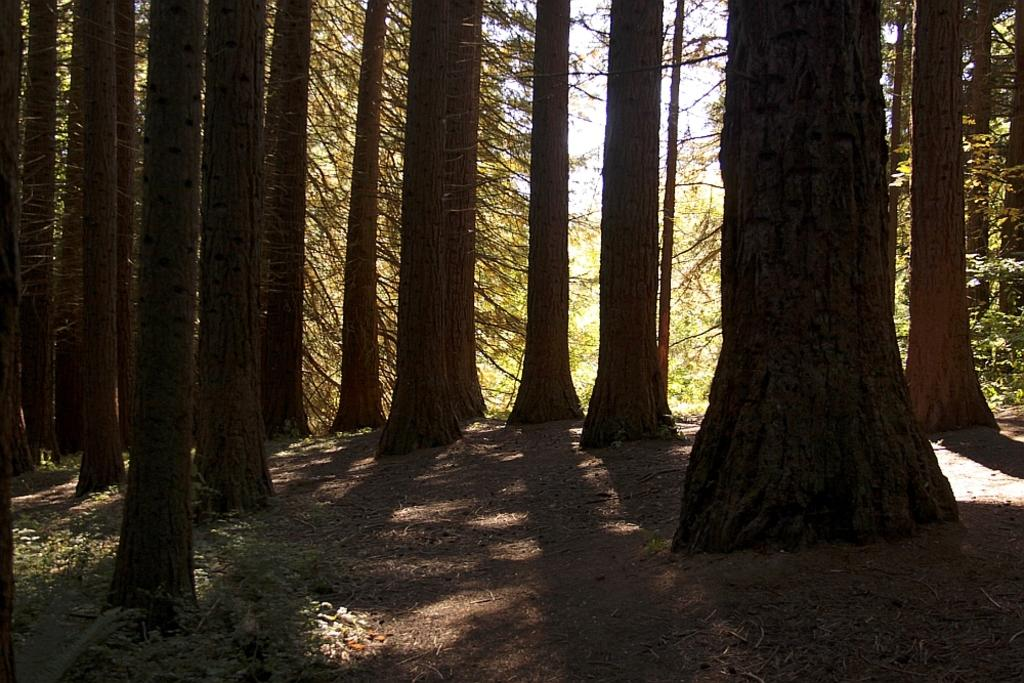What is the primary feature in the foreground of the image? There are many trees in the foreground of the image. What can be seen in the background of the image? The sky is visible in the background of the image. Where is the coat hanging in the image? There is no coat present in the image. What type of carriage can be seen in the image? There is no carriage present in the image. 